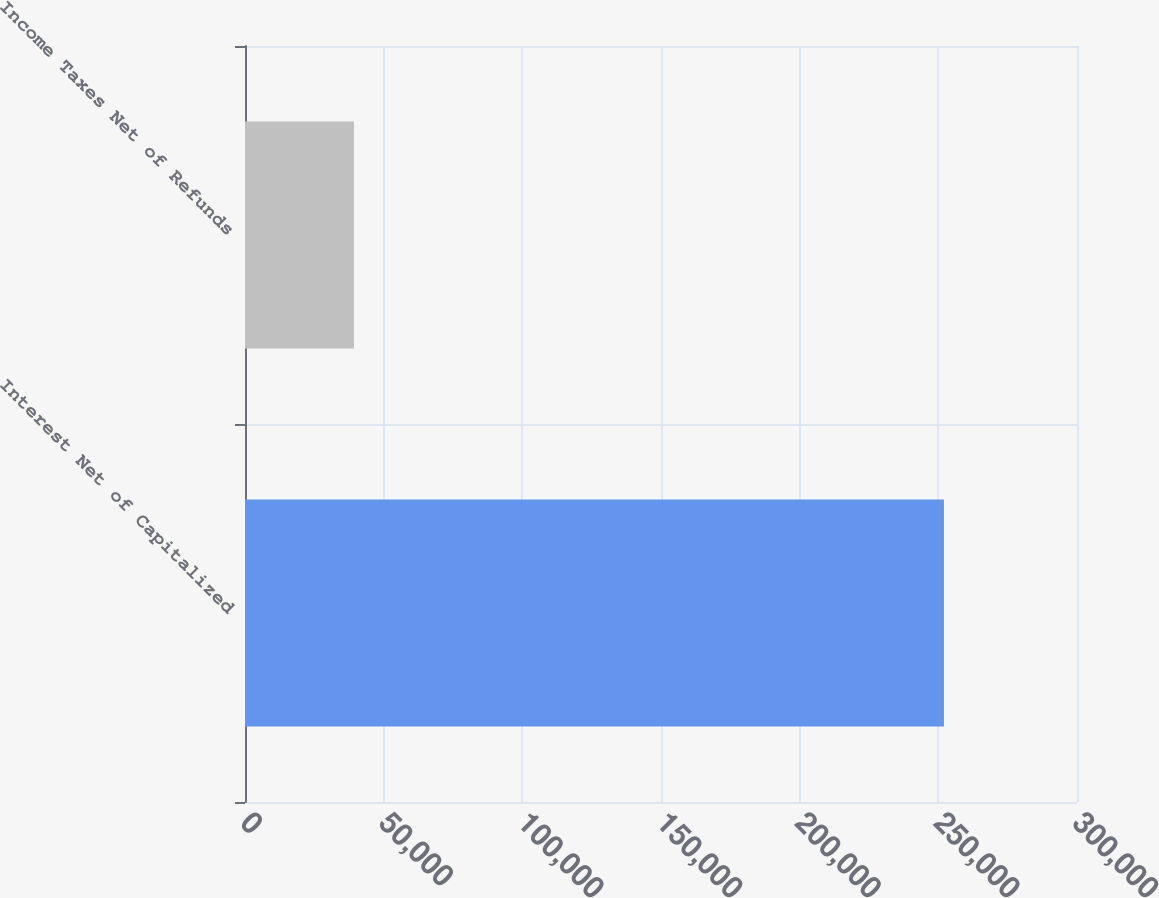<chart> <loc_0><loc_0><loc_500><loc_500><bar_chart><fcel>Interest Net of Capitalized<fcel>Income Taxes Net of Refunds<nl><fcel>252030<fcel>39293<nl></chart> 